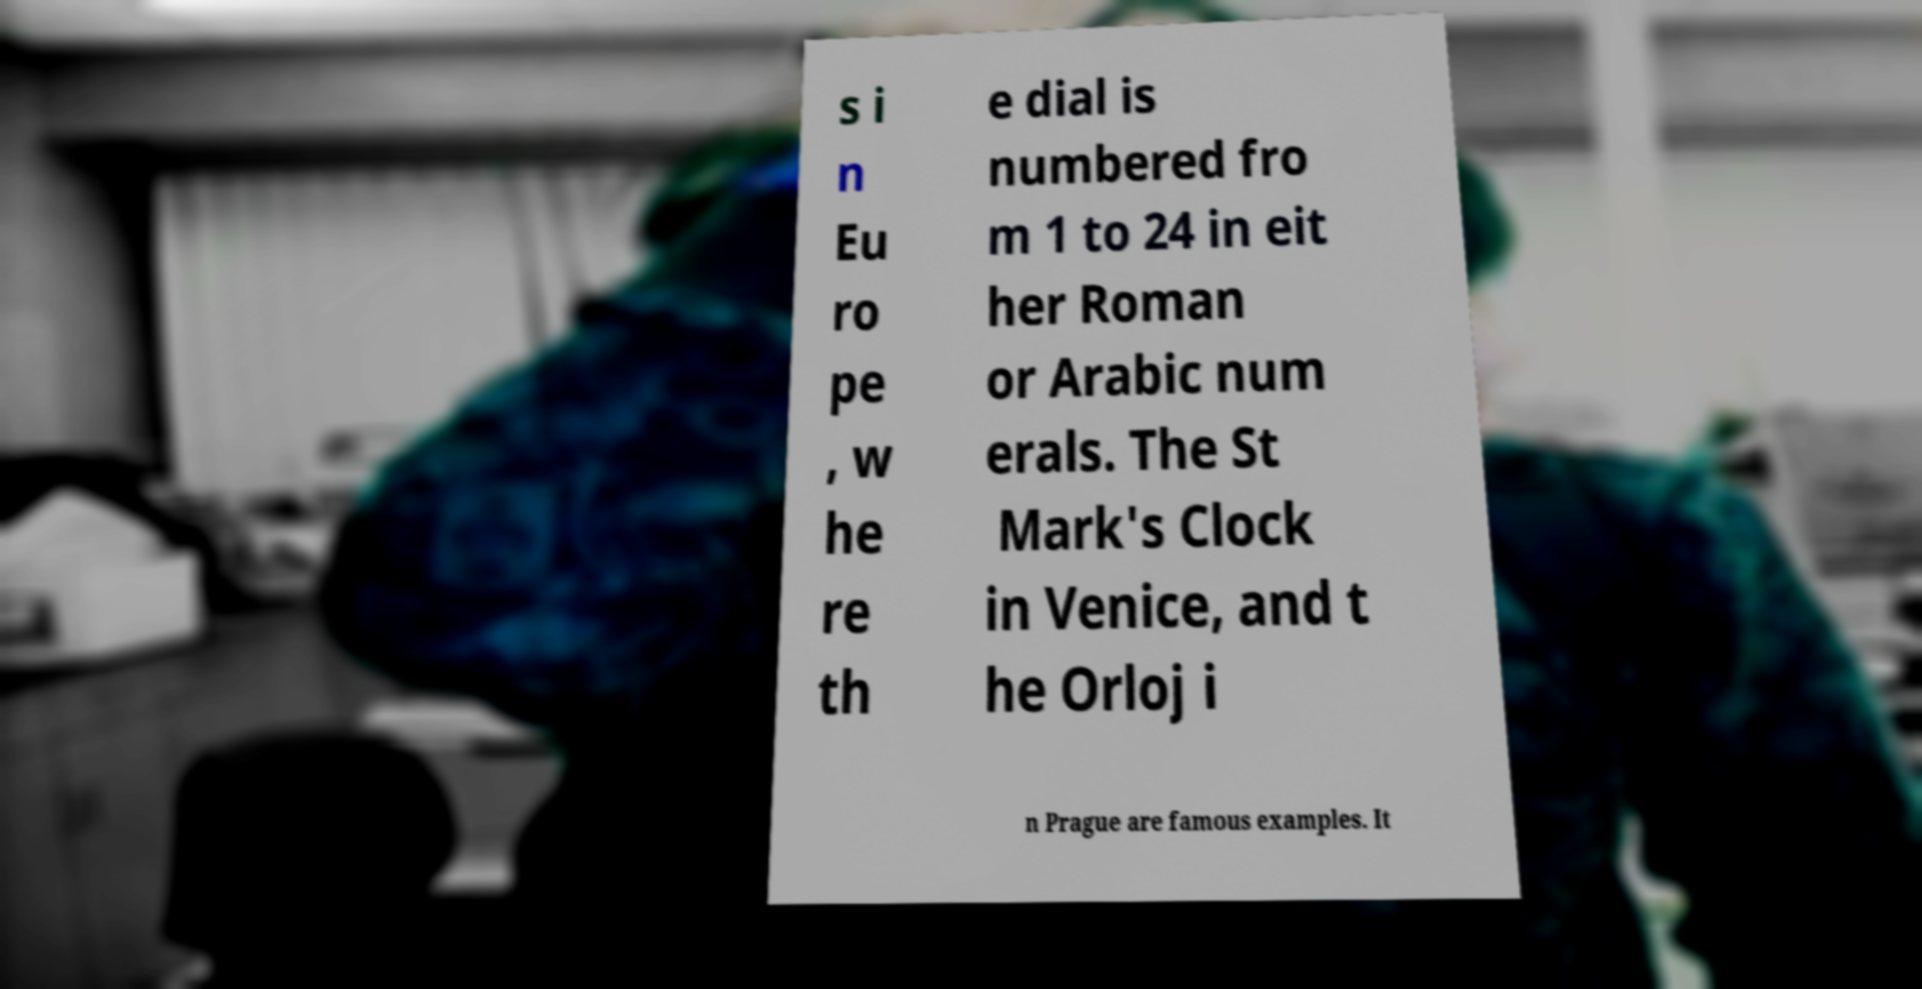I need the written content from this picture converted into text. Can you do that? s i n Eu ro pe , w he re th e dial is numbered fro m 1 to 24 in eit her Roman or Arabic num erals. The St Mark's Clock in Venice, and t he Orloj i n Prague are famous examples. It 